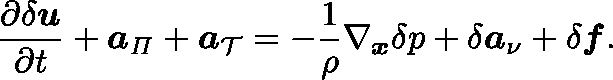Convert formula to latex. <formula><loc_0><loc_0><loc_500><loc_500>\frac { \partial \delta u } { \partial t } + a _ { \Pi } + a _ { \mathcal { T } } = - \frac { 1 } { \rho } \nabla _ { x } \delta p + \delta a _ { \nu } + \delta f .</formula> 